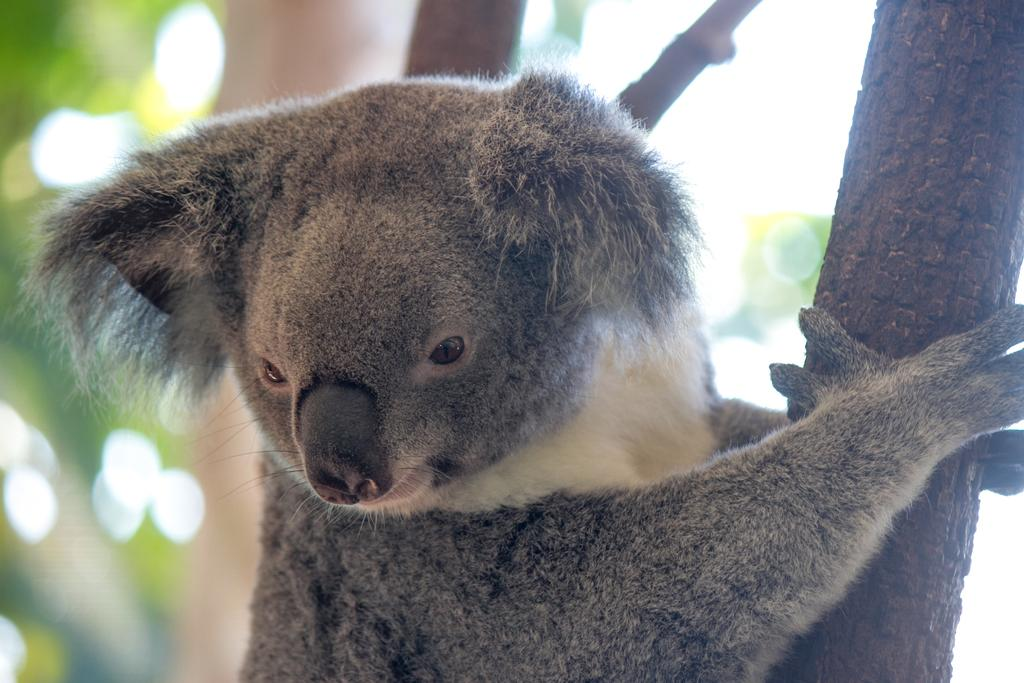What is the main subject in the middle of the image? There is an animal in the middle of the image. What can be seen on the right side of the image? There is a bark of a tree on the right side of the image. Where is the pan located in the image? There is no pan present in the image. Who is the manager in the image? There is no manager present in the image. 